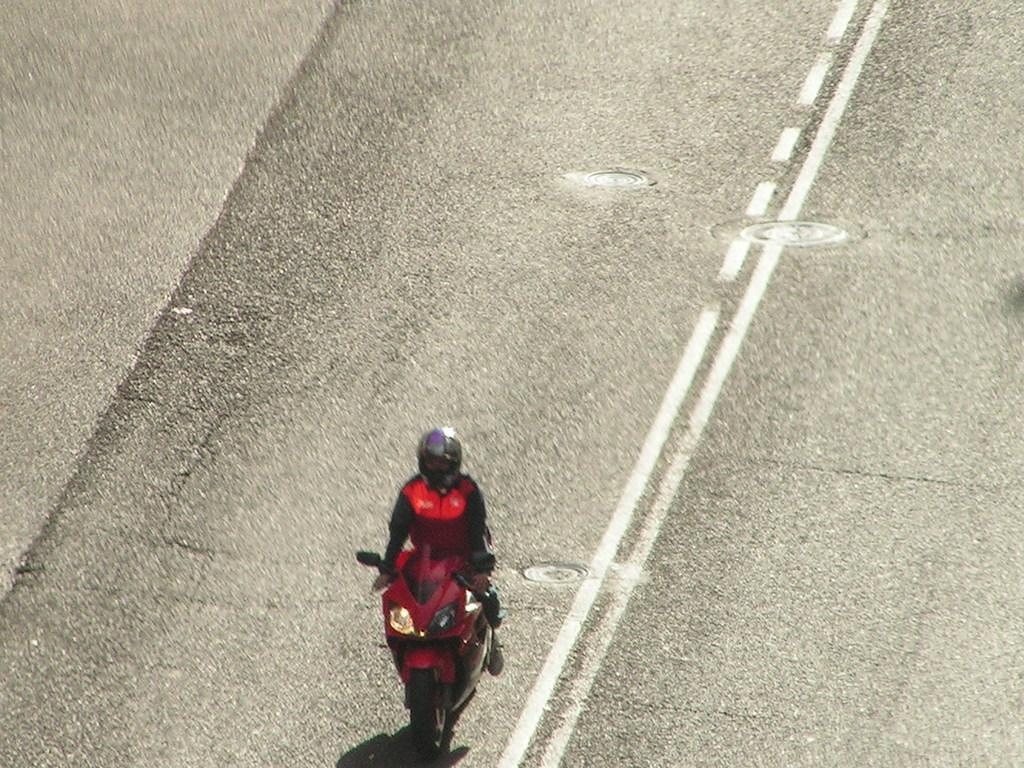Who is in the image? There is a person in the image. What is the person wearing? The person is wearing a red jacket. What is the person riding in the image? The person is riding a red bike. Where is the bike located? The bike is on the road. What can be seen on the road in the image? There are white lines on the road. What sound does the person's father make while laughing in the image? There is no father or laughter present in the image; it only features a person riding a red bike on the road. 